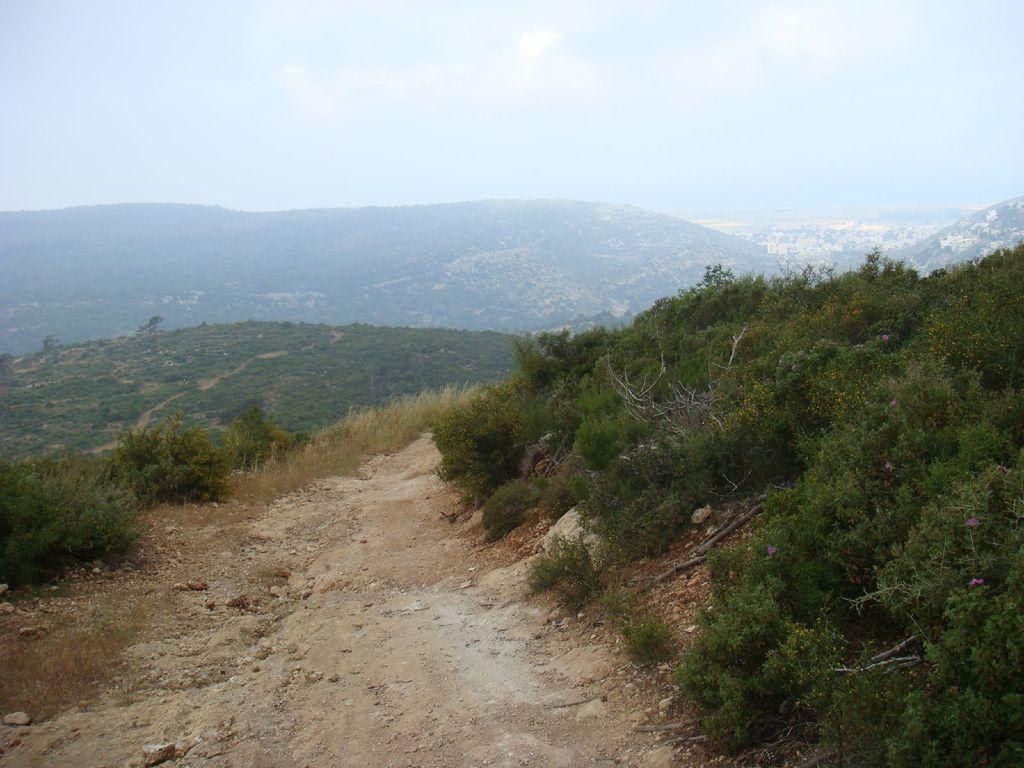What type of vegetation can be seen in the image? There are plants, grass, and trees visible in the image. What is the terrain like in the image? The terrain includes hills visible in the background of the image. What is the condition of the sky in the image? The sky is visible in the image and appears cloudy. Can you see any dinosaurs walking on the sidewalk in the image? There are no dinosaurs or sidewalks present in the image. 